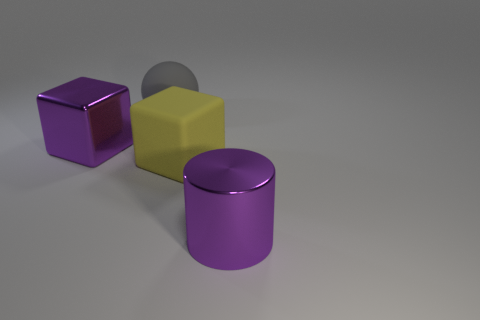If this were a still life painting, what mood might the artist be trying to convey? If this were a still life painting, the artist might be attempting to evoke a sense of calm and simplicity through the minimalistic arrangement of the objects and the soothing color palette. The choice of reflective and matte surfaces could be an exploration of contrast and harmony, inviting contemplation on texture and form. 